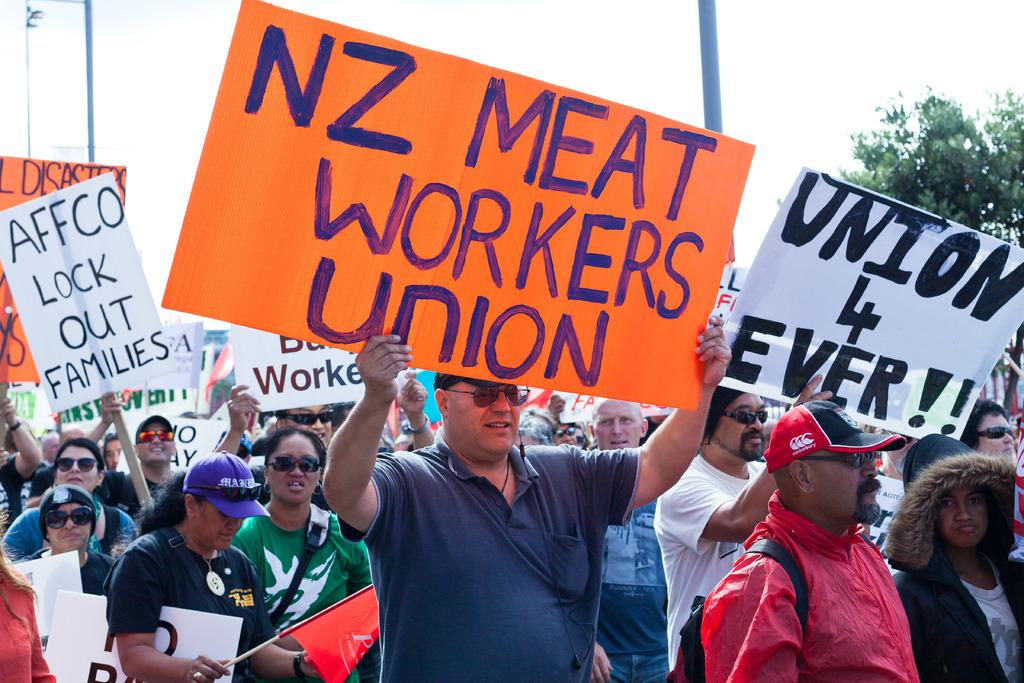What is happening in the image involving the group of people? The people in the image are standing and holding placards and boards. What else can be seen in the image besides the group of people? There is a tree in the image, and the sky is visible in the background. What type of crown is being worn by the tree in the image? There is no crown present in the image, as the tree is a natural element and does not wear any accessories. 